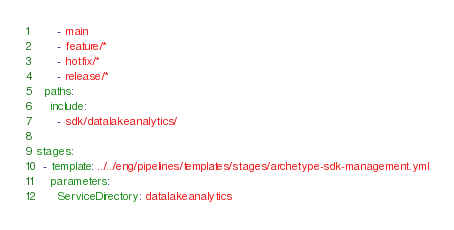Convert code to text. <code><loc_0><loc_0><loc_500><loc_500><_YAML_>      - main
      - feature/*
      - hotfix/*
      - release/*
  paths:
    include:
      - sdk/datalakeanalytics/

stages:
  - template: ../../eng/pipelines/templates/stages/archetype-sdk-management.yml
    parameters:
      ServiceDirectory: datalakeanalytics
</code> 